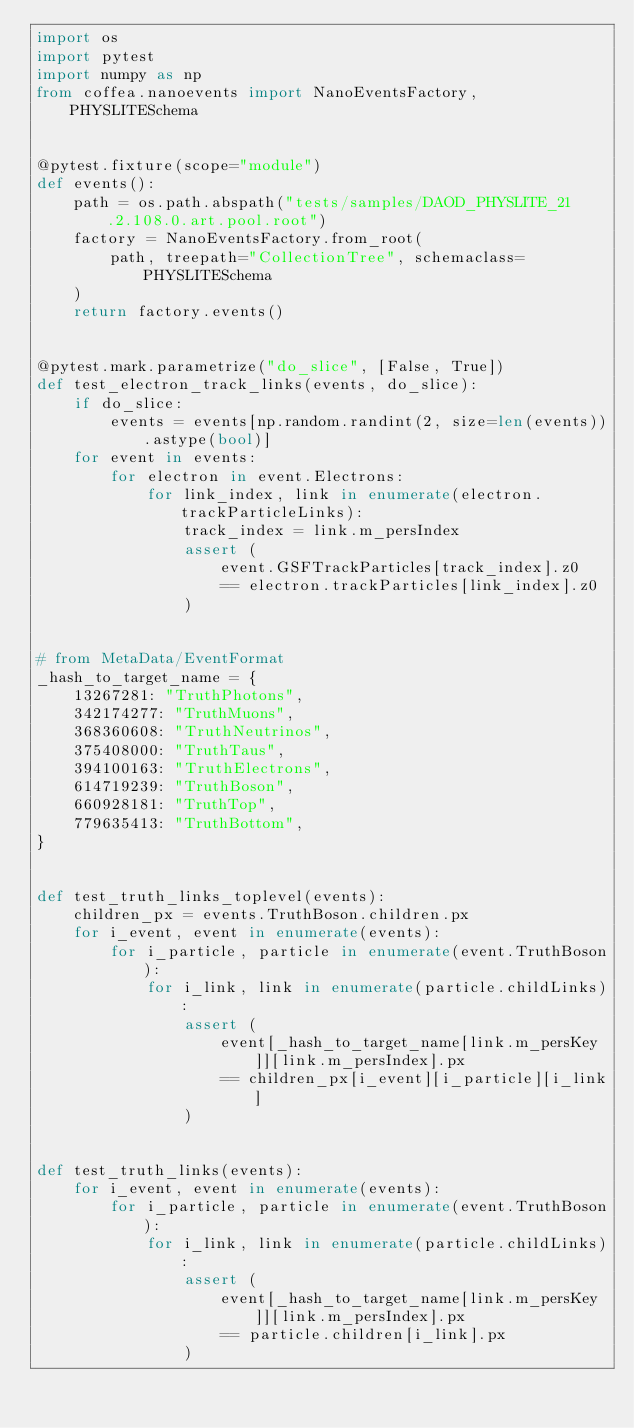Convert code to text. <code><loc_0><loc_0><loc_500><loc_500><_Python_>import os
import pytest
import numpy as np
from coffea.nanoevents import NanoEventsFactory, PHYSLITESchema


@pytest.fixture(scope="module")
def events():
    path = os.path.abspath("tests/samples/DAOD_PHYSLITE_21.2.108.0.art.pool.root")
    factory = NanoEventsFactory.from_root(
        path, treepath="CollectionTree", schemaclass=PHYSLITESchema
    )
    return factory.events()


@pytest.mark.parametrize("do_slice", [False, True])
def test_electron_track_links(events, do_slice):
    if do_slice:
        events = events[np.random.randint(2, size=len(events)).astype(bool)]
    for event in events:
        for electron in event.Electrons:
            for link_index, link in enumerate(electron.trackParticleLinks):
                track_index = link.m_persIndex
                assert (
                    event.GSFTrackParticles[track_index].z0
                    == electron.trackParticles[link_index].z0
                )


# from MetaData/EventFormat
_hash_to_target_name = {
    13267281: "TruthPhotons",
    342174277: "TruthMuons",
    368360608: "TruthNeutrinos",
    375408000: "TruthTaus",
    394100163: "TruthElectrons",
    614719239: "TruthBoson",
    660928181: "TruthTop",
    779635413: "TruthBottom",
}


def test_truth_links_toplevel(events):
    children_px = events.TruthBoson.children.px
    for i_event, event in enumerate(events):
        for i_particle, particle in enumerate(event.TruthBoson):
            for i_link, link in enumerate(particle.childLinks):
                assert (
                    event[_hash_to_target_name[link.m_persKey]][link.m_persIndex].px
                    == children_px[i_event][i_particle][i_link]
                )


def test_truth_links(events):
    for i_event, event in enumerate(events):
        for i_particle, particle in enumerate(event.TruthBoson):
            for i_link, link in enumerate(particle.childLinks):
                assert (
                    event[_hash_to_target_name[link.m_persKey]][link.m_persIndex].px
                    == particle.children[i_link].px
                )
</code> 